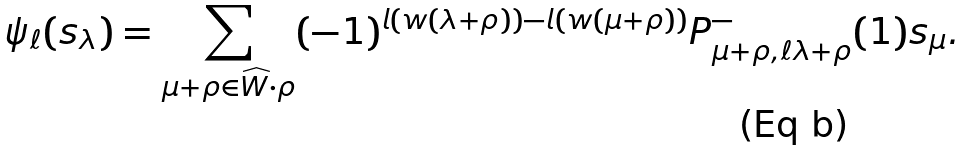<formula> <loc_0><loc_0><loc_500><loc_500>\psi _ { \ell } ( s _ { \lambda } ) = \sum _ { \mu + \rho \in \widehat { W } \cdot \rho } ( - 1 ) ^ { l ( w ( \lambda + \rho ) ) - l ( w ( \mu + \rho ) ) } P _ { \mu + \rho , \ell \lambda + \rho } ^ { - } ( 1 ) s _ { \mu } .</formula> 